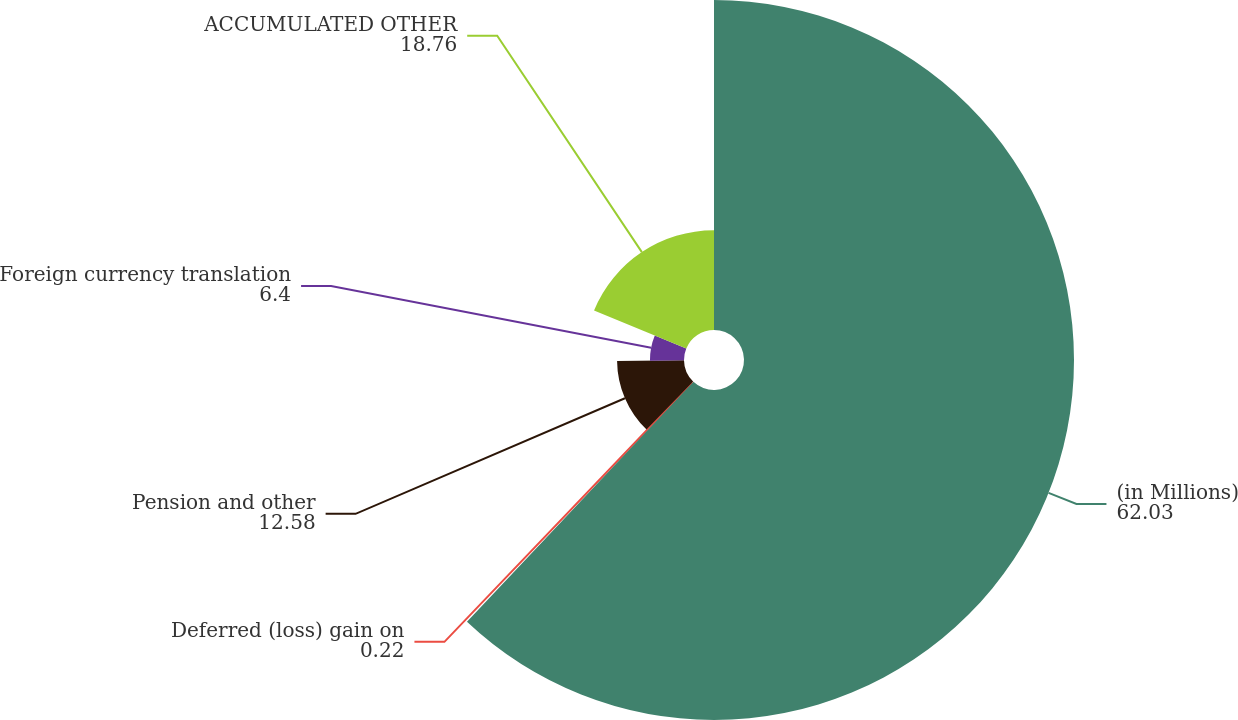Convert chart to OTSL. <chart><loc_0><loc_0><loc_500><loc_500><pie_chart><fcel>(in Millions)<fcel>Deferred (loss) gain on<fcel>Pension and other<fcel>Foreign currency translation<fcel>ACCUMULATED OTHER<nl><fcel>62.03%<fcel>0.22%<fcel>12.58%<fcel>6.4%<fcel>18.76%<nl></chart> 